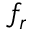<formula> <loc_0><loc_0><loc_500><loc_500>f _ { r }</formula> 